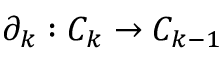Convert formula to latex. <formula><loc_0><loc_0><loc_500><loc_500>\partial _ { k } \colon C _ { k } \to C _ { k - 1 }</formula> 